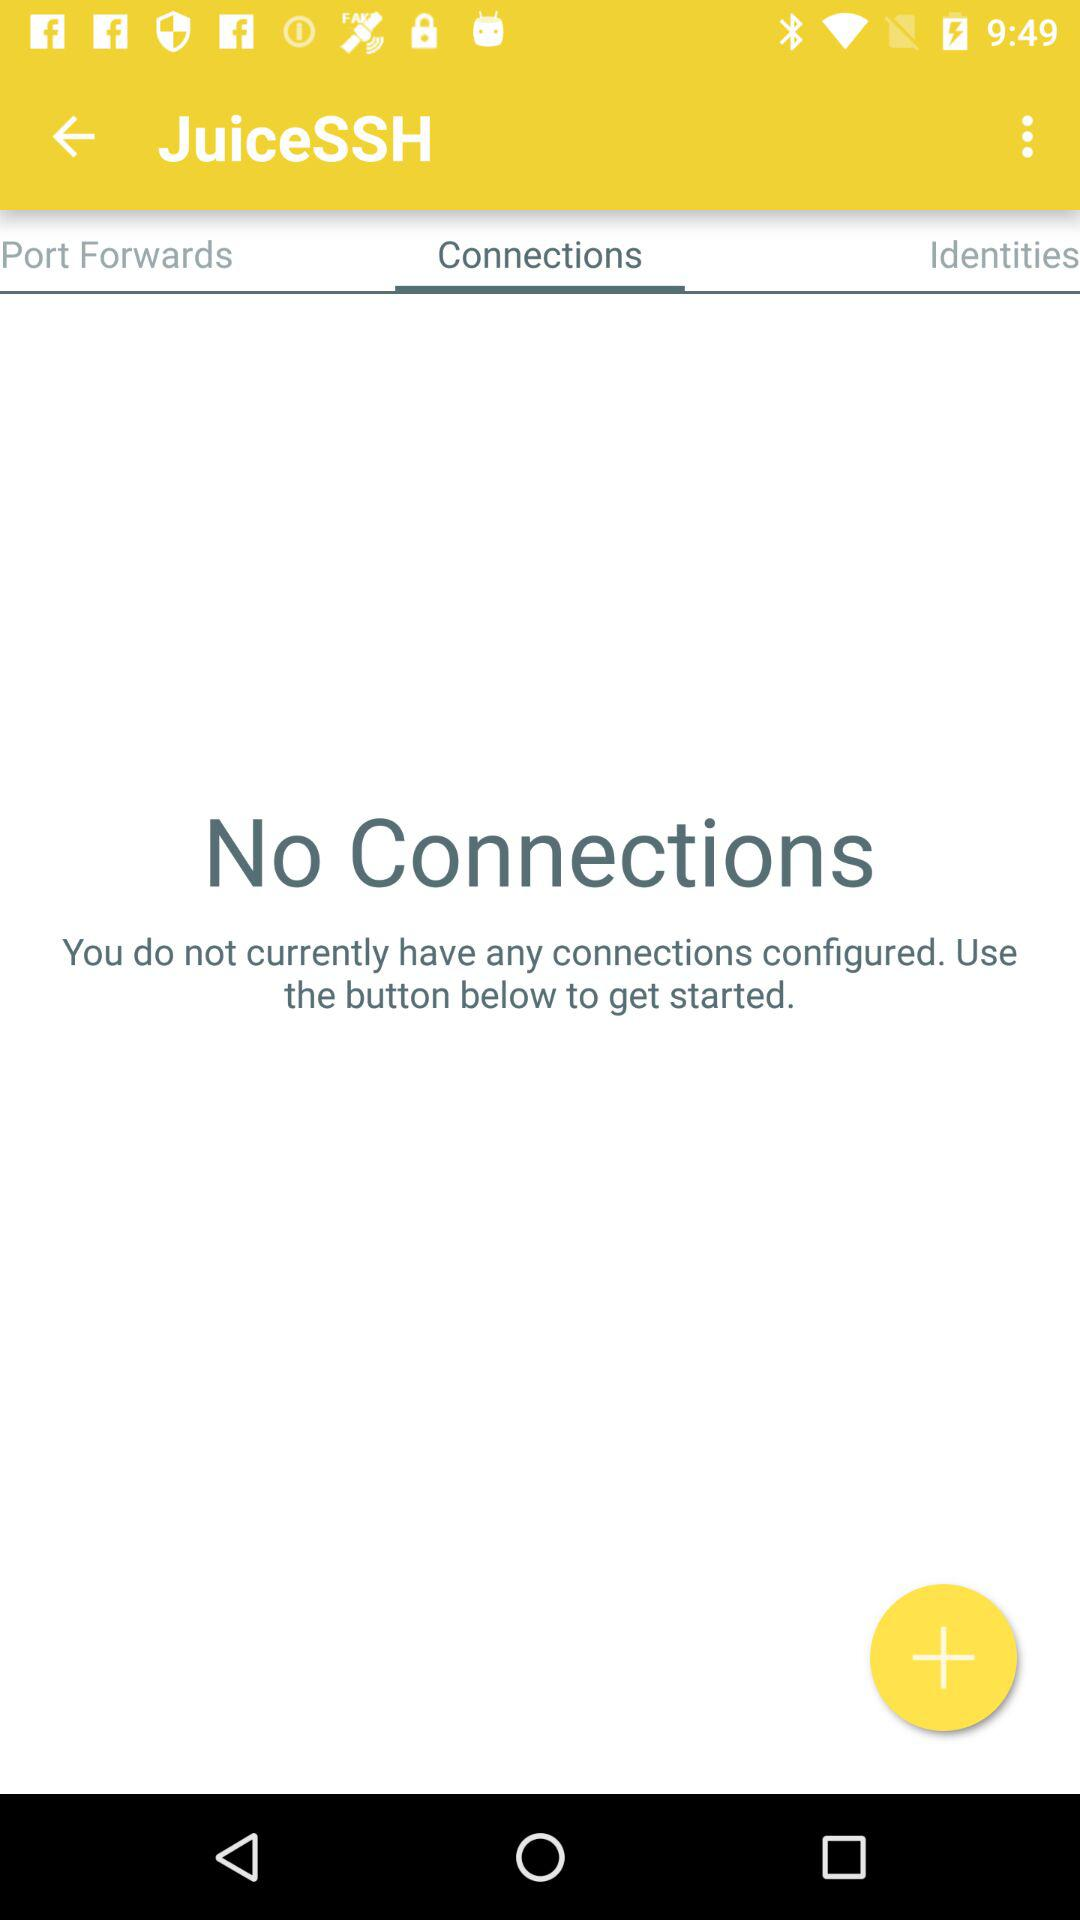How many connections are there right now? There is no connection right now. 